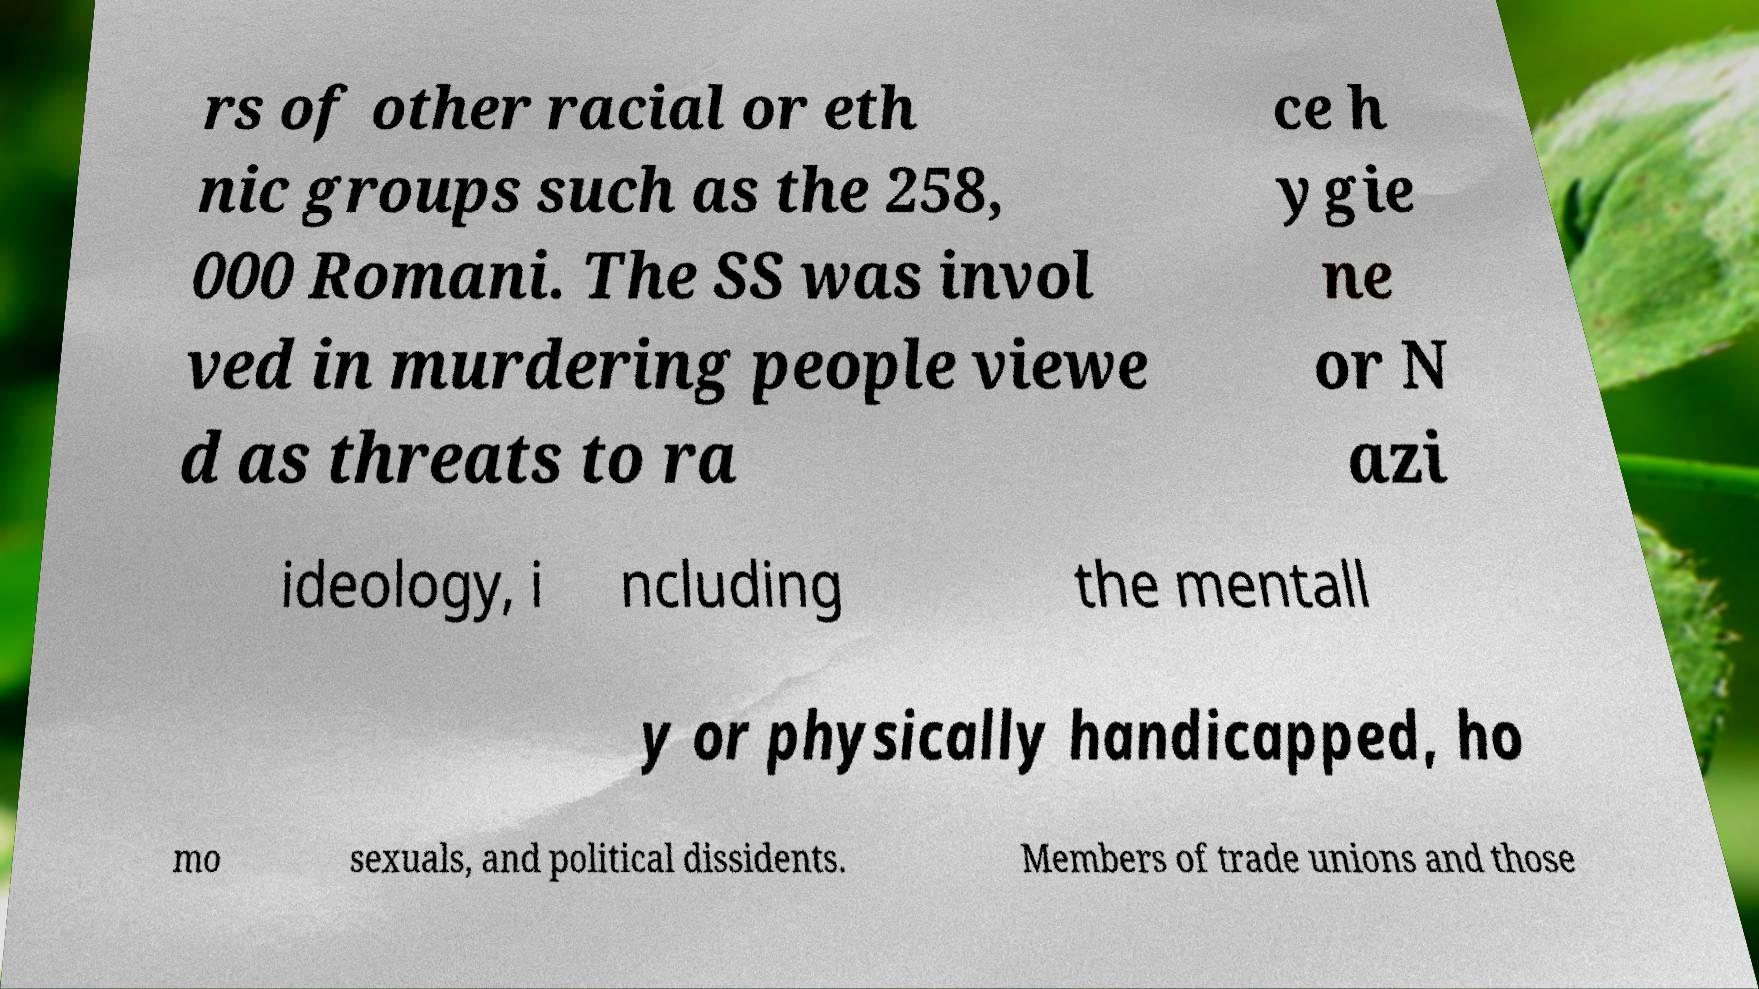Can you read and provide the text displayed in the image?This photo seems to have some interesting text. Can you extract and type it out for me? rs of other racial or eth nic groups such as the 258, 000 Romani. The SS was invol ved in murdering people viewe d as threats to ra ce h ygie ne or N azi ideology, i ncluding the mentall y or physically handicapped, ho mo sexuals, and political dissidents. Members of trade unions and those 